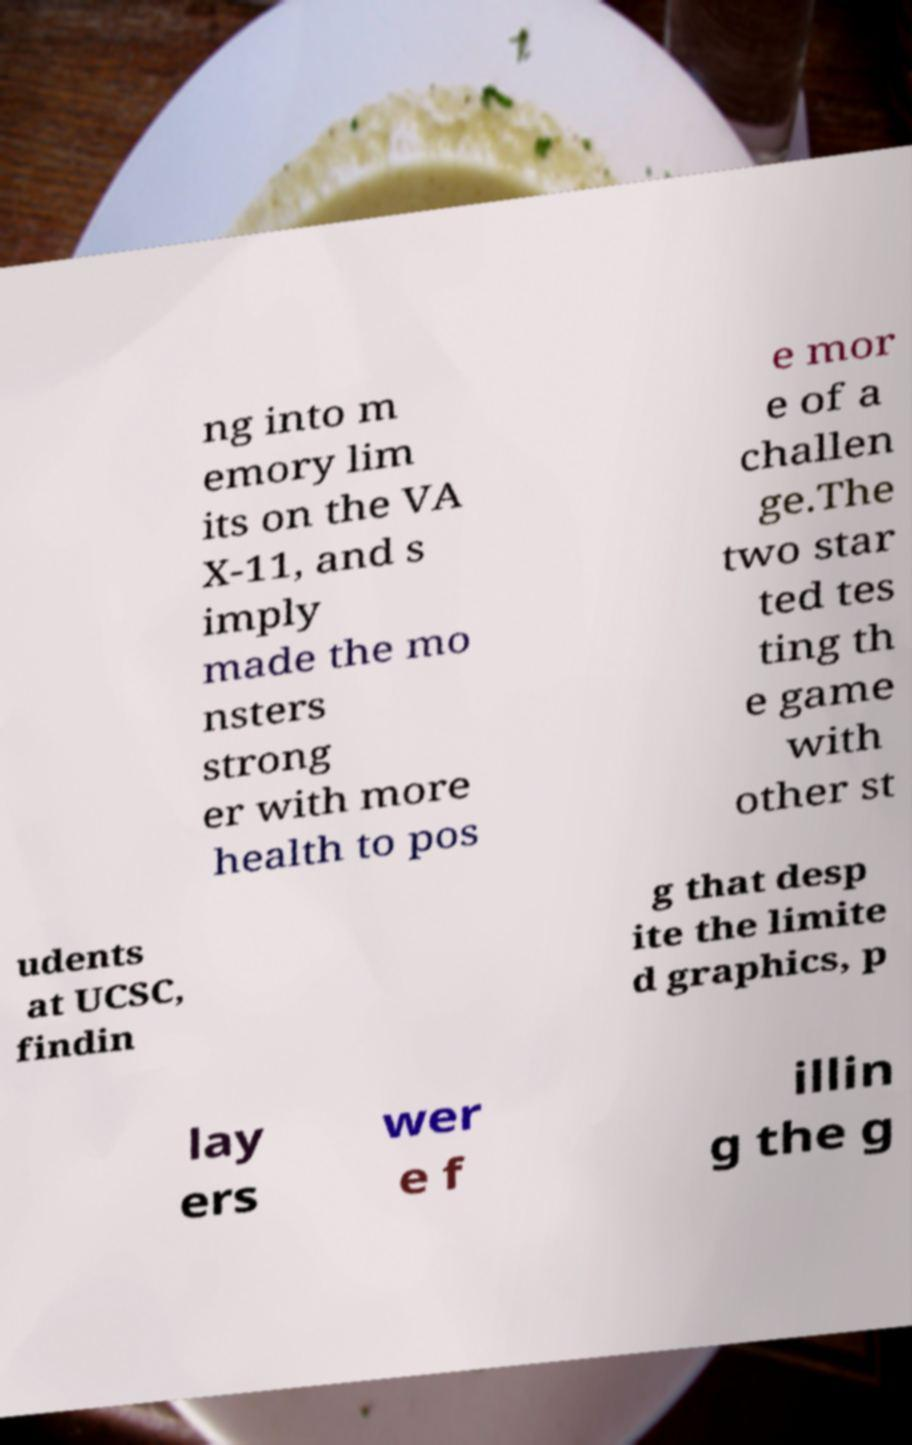There's text embedded in this image that I need extracted. Can you transcribe it verbatim? ng into m emory lim its on the VA X-11, and s imply made the mo nsters strong er with more health to pos e mor e of a challen ge.The two star ted tes ting th e game with other st udents at UCSC, findin g that desp ite the limite d graphics, p lay ers wer e f illin g the g 